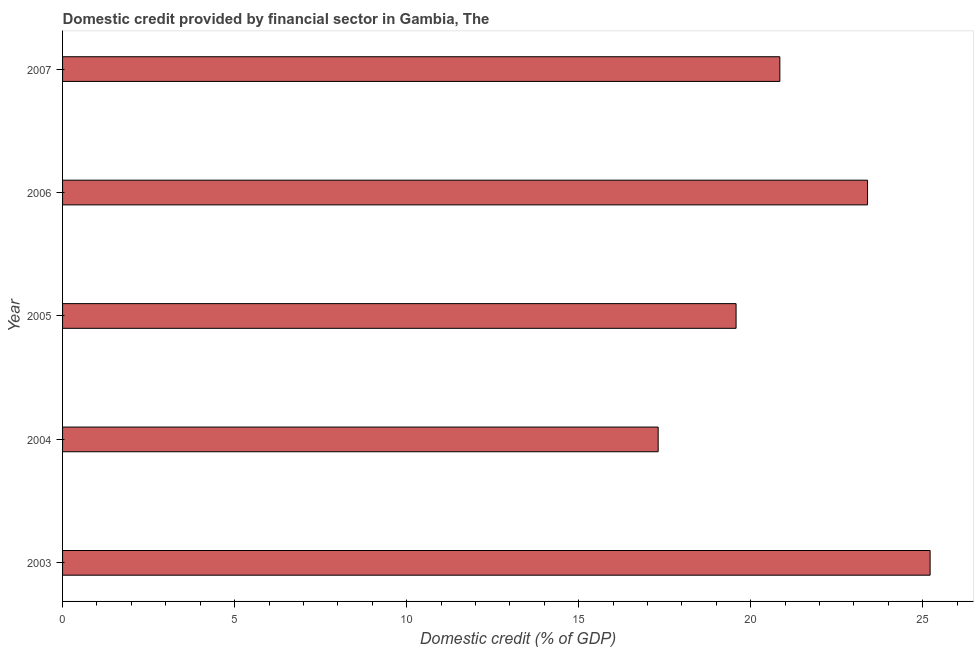Does the graph contain grids?
Provide a short and direct response. No. What is the title of the graph?
Give a very brief answer. Domestic credit provided by financial sector in Gambia, The. What is the label or title of the X-axis?
Provide a succinct answer. Domestic credit (% of GDP). What is the domestic credit provided by financial sector in 2004?
Provide a succinct answer. 17.31. Across all years, what is the maximum domestic credit provided by financial sector?
Your response must be concise. 25.21. Across all years, what is the minimum domestic credit provided by financial sector?
Provide a succinct answer. 17.31. In which year was the domestic credit provided by financial sector minimum?
Give a very brief answer. 2004. What is the sum of the domestic credit provided by financial sector?
Offer a terse response. 106.33. What is the difference between the domestic credit provided by financial sector in 2004 and 2007?
Offer a very short reply. -3.54. What is the average domestic credit provided by financial sector per year?
Your response must be concise. 21.27. What is the median domestic credit provided by financial sector?
Keep it short and to the point. 20.85. Do a majority of the years between 2003 and 2007 (inclusive) have domestic credit provided by financial sector greater than 20 %?
Your answer should be very brief. Yes. What is the ratio of the domestic credit provided by financial sector in 2004 to that in 2007?
Make the answer very short. 0.83. Is the domestic credit provided by financial sector in 2005 less than that in 2007?
Offer a terse response. Yes. Is the difference between the domestic credit provided by financial sector in 2005 and 2006 greater than the difference between any two years?
Keep it short and to the point. No. What is the difference between the highest and the second highest domestic credit provided by financial sector?
Ensure brevity in your answer.  1.82. Is the sum of the domestic credit provided by financial sector in 2006 and 2007 greater than the maximum domestic credit provided by financial sector across all years?
Keep it short and to the point. Yes. What is the difference between the highest and the lowest domestic credit provided by financial sector?
Provide a short and direct response. 7.9. How many bars are there?
Offer a terse response. 5. Are all the bars in the graph horizontal?
Keep it short and to the point. Yes. Are the values on the major ticks of X-axis written in scientific E-notation?
Ensure brevity in your answer.  No. What is the Domestic credit (% of GDP) of 2003?
Your response must be concise. 25.21. What is the Domestic credit (% of GDP) of 2004?
Give a very brief answer. 17.31. What is the Domestic credit (% of GDP) in 2005?
Your answer should be compact. 19.57. What is the Domestic credit (% of GDP) in 2006?
Offer a very short reply. 23.39. What is the Domestic credit (% of GDP) in 2007?
Offer a very short reply. 20.85. What is the difference between the Domestic credit (% of GDP) in 2003 and 2004?
Your response must be concise. 7.9. What is the difference between the Domestic credit (% of GDP) in 2003 and 2005?
Provide a succinct answer. 5.64. What is the difference between the Domestic credit (% of GDP) in 2003 and 2006?
Provide a succinct answer. 1.82. What is the difference between the Domestic credit (% of GDP) in 2003 and 2007?
Ensure brevity in your answer.  4.37. What is the difference between the Domestic credit (% of GDP) in 2004 and 2005?
Your answer should be very brief. -2.26. What is the difference between the Domestic credit (% of GDP) in 2004 and 2006?
Make the answer very short. -6.08. What is the difference between the Domestic credit (% of GDP) in 2004 and 2007?
Your response must be concise. -3.54. What is the difference between the Domestic credit (% of GDP) in 2005 and 2006?
Ensure brevity in your answer.  -3.82. What is the difference between the Domestic credit (% of GDP) in 2005 and 2007?
Make the answer very short. -1.27. What is the difference between the Domestic credit (% of GDP) in 2006 and 2007?
Provide a succinct answer. 2.55. What is the ratio of the Domestic credit (% of GDP) in 2003 to that in 2004?
Keep it short and to the point. 1.46. What is the ratio of the Domestic credit (% of GDP) in 2003 to that in 2005?
Your answer should be very brief. 1.29. What is the ratio of the Domestic credit (% of GDP) in 2003 to that in 2006?
Give a very brief answer. 1.08. What is the ratio of the Domestic credit (% of GDP) in 2003 to that in 2007?
Your answer should be compact. 1.21. What is the ratio of the Domestic credit (% of GDP) in 2004 to that in 2005?
Your response must be concise. 0.88. What is the ratio of the Domestic credit (% of GDP) in 2004 to that in 2006?
Offer a terse response. 0.74. What is the ratio of the Domestic credit (% of GDP) in 2004 to that in 2007?
Your answer should be very brief. 0.83. What is the ratio of the Domestic credit (% of GDP) in 2005 to that in 2006?
Offer a terse response. 0.84. What is the ratio of the Domestic credit (% of GDP) in 2005 to that in 2007?
Offer a terse response. 0.94. What is the ratio of the Domestic credit (% of GDP) in 2006 to that in 2007?
Provide a short and direct response. 1.12. 